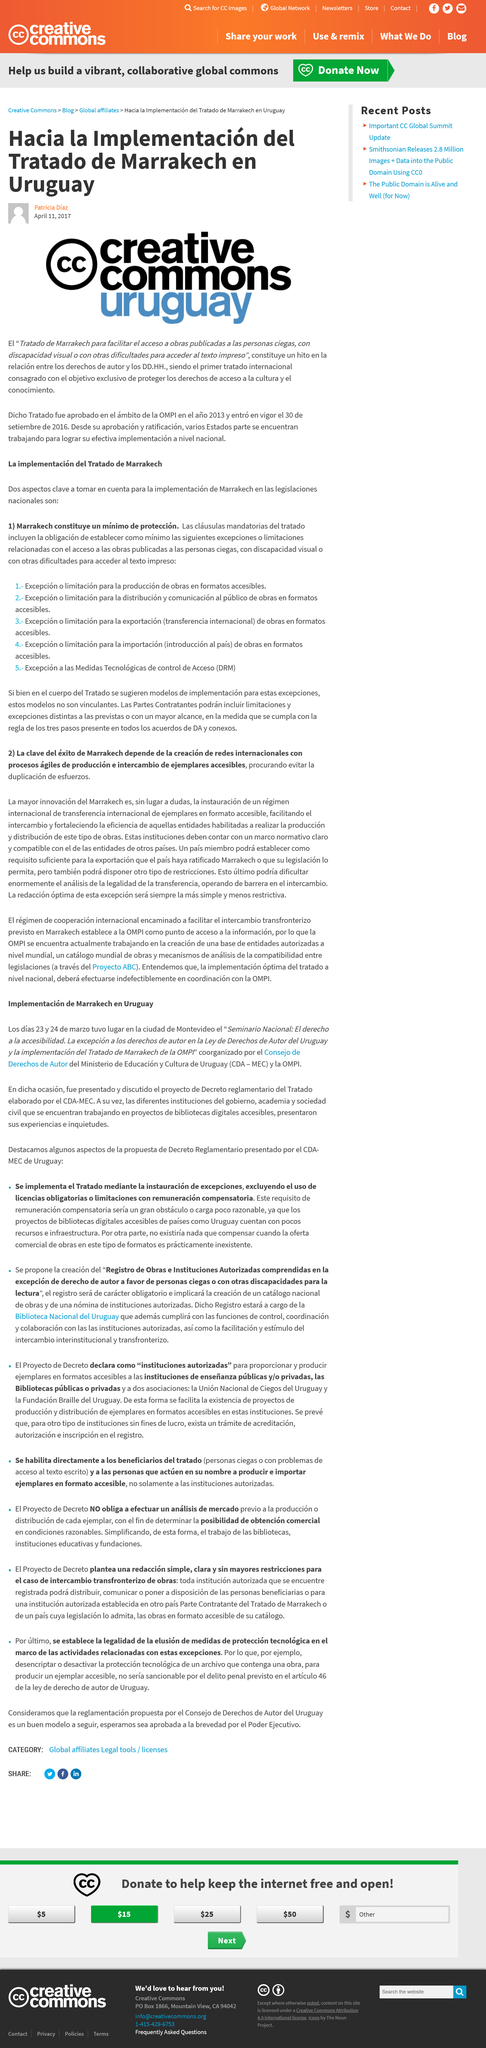Identify some key points in this picture. The text is written in Spanish. The article was written on April 11, 2017. The author of this article is Patricia Diaz. 